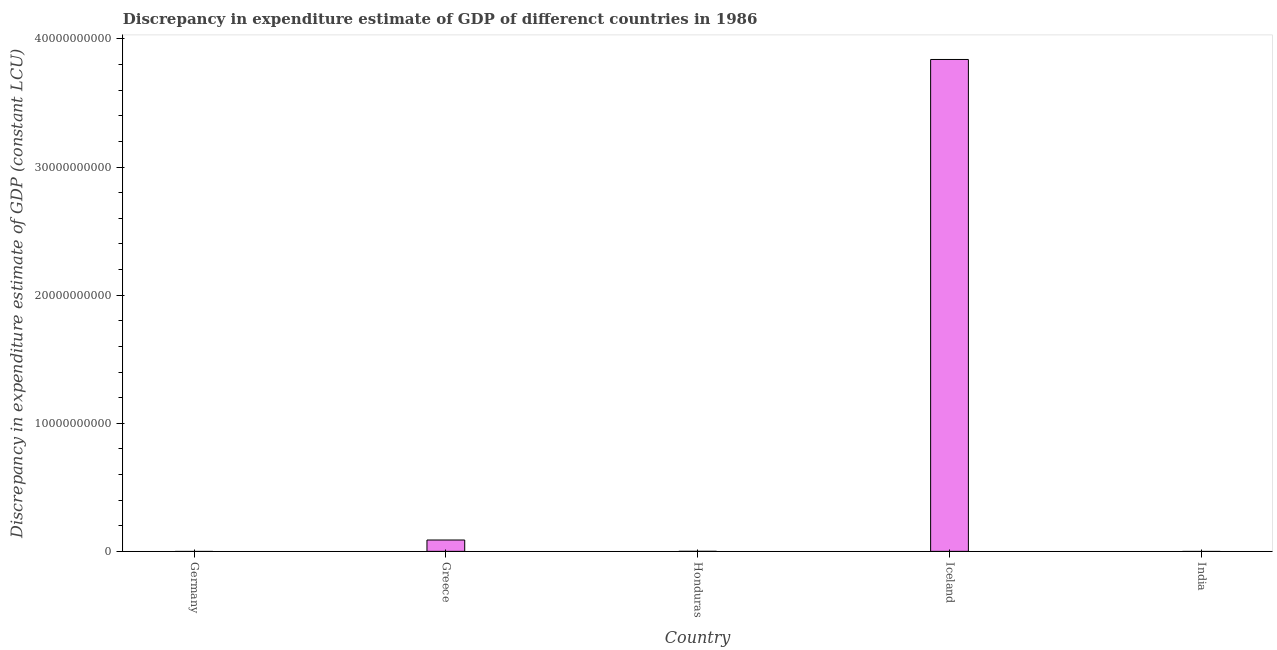What is the title of the graph?
Ensure brevity in your answer.  Discrepancy in expenditure estimate of GDP of differenct countries in 1986. What is the label or title of the Y-axis?
Provide a short and direct response. Discrepancy in expenditure estimate of GDP (constant LCU). What is the discrepancy in expenditure estimate of gdp in Iceland?
Provide a succinct answer. 3.84e+1. Across all countries, what is the maximum discrepancy in expenditure estimate of gdp?
Give a very brief answer. 3.84e+1. In which country was the discrepancy in expenditure estimate of gdp maximum?
Your answer should be compact. Iceland. What is the sum of the discrepancy in expenditure estimate of gdp?
Offer a very short reply. 3.93e+1. What is the difference between the discrepancy in expenditure estimate of gdp in Honduras and Iceland?
Offer a terse response. -3.84e+1. What is the average discrepancy in expenditure estimate of gdp per country?
Your response must be concise. 7.86e+09. What is the median discrepancy in expenditure estimate of gdp?
Your answer should be very brief. 6.77e+04. In how many countries, is the discrepancy in expenditure estimate of gdp greater than 18000000000 LCU?
Your answer should be very brief. 1. What is the ratio of the discrepancy in expenditure estimate of gdp in Greece to that in Honduras?
Your answer should be very brief. 1.31e+04. Is the difference between the discrepancy in expenditure estimate of gdp in Greece and Iceland greater than the difference between any two countries?
Keep it short and to the point. No. What is the difference between the highest and the second highest discrepancy in expenditure estimate of gdp?
Your answer should be very brief. 3.75e+1. What is the difference between the highest and the lowest discrepancy in expenditure estimate of gdp?
Your answer should be compact. 3.84e+1. How many countries are there in the graph?
Your answer should be very brief. 5. What is the Discrepancy in expenditure estimate of GDP (constant LCU) of Germany?
Offer a very short reply. 0. What is the Discrepancy in expenditure estimate of GDP (constant LCU) in Greece?
Your answer should be compact. 8.86e+08. What is the Discrepancy in expenditure estimate of GDP (constant LCU) of Honduras?
Give a very brief answer. 6.77e+04. What is the Discrepancy in expenditure estimate of GDP (constant LCU) in Iceland?
Your answer should be very brief. 3.84e+1. What is the difference between the Discrepancy in expenditure estimate of GDP (constant LCU) in Greece and Honduras?
Keep it short and to the point. 8.86e+08. What is the difference between the Discrepancy in expenditure estimate of GDP (constant LCU) in Greece and Iceland?
Provide a succinct answer. -3.75e+1. What is the difference between the Discrepancy in expenditure estimate of GDP (constant LCU) in Honduras and Iceland?
Offer a very short reply. -3.84e+1. What is the ratio of the Discrepancy in expenditure estimate of GDP (constant LCU) in Greece to that in Honduras?
Make the answer very short. 1.31e+04. What is the ratio of the Discrepancy in expenditure estimate of GDP (constant LCU) in Greece to that in Iceland?
Offer a very short reply. 0.02. What is the ratio of the Discrepancy in expenditure estimate of GDP (constant LCU) in Honduras to that in Iceland?
Provide a short and direct response. 0. 